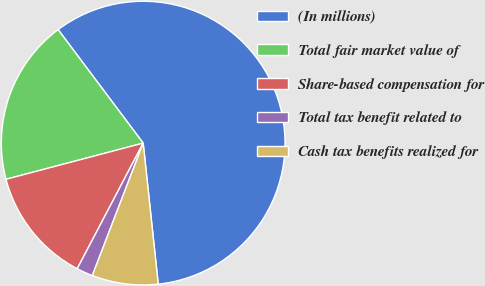Convert chart. <chart><loc_0><loc_0><loc_500><loc_500><pie_chart><fcel>(In millions)<fcel>Total fair market value of<fcel>Share-based compensation for<fcel>Total tax benefit related to<fcel>Cash tax benefits realized for<nl><fcel>58.55%<fcel>18.87%<fcel>13.2%<fcel>1.86%<fcel>7.53%<nl></chart> 